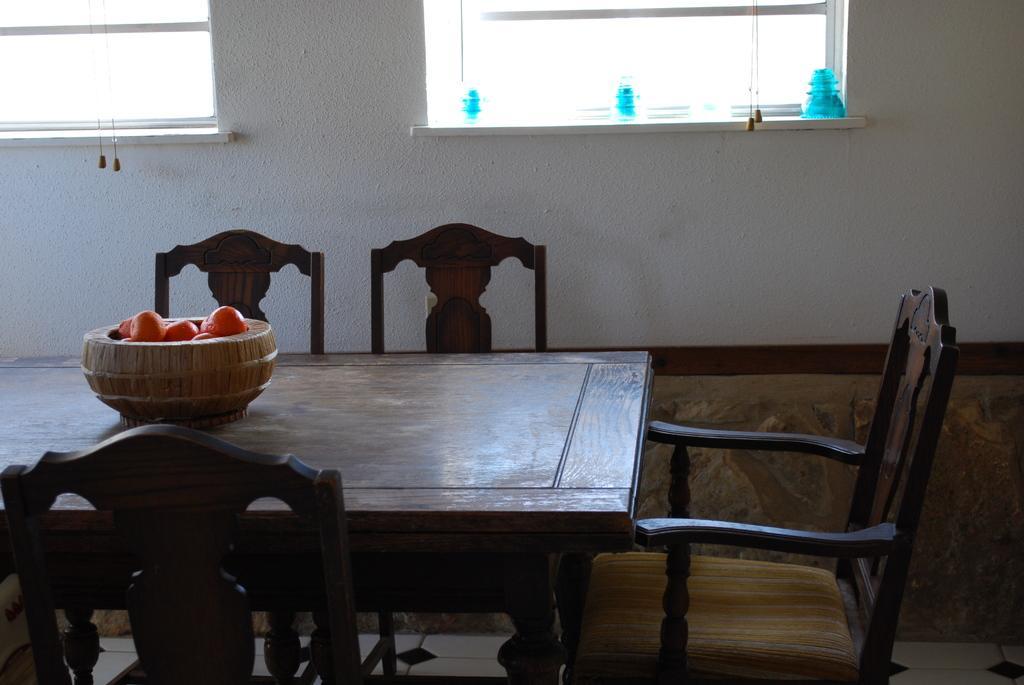Describe this image in one or two sentences. In this image I see a table on which there is a container in which there are few things and there are 4 chairs around the table, In the background I see the wall and the windows. 